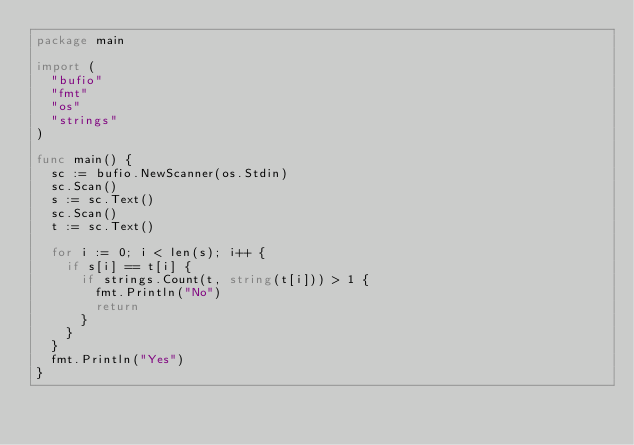<code> <loc_0><loc_0><loc_500><loc_500><_Go_>package main

import (
	"bufio"
	"fmt"
	"os"
	"strings"
)

func main() {
	sc := bufio.NewScanner(os.Stdin)
	sc.Scan()
	s := sc.Text()
	sc.Scan()
	t := sc.Text()

	for i := 0; i < len(s); i++ {
		if s[i] == t[i] {
			if strings.Count(t, string(t[i])) > 1 {
				fmt.Println("No")
				return
			}
		}
	}
	fmt.Println("Yes")
}
</code> 